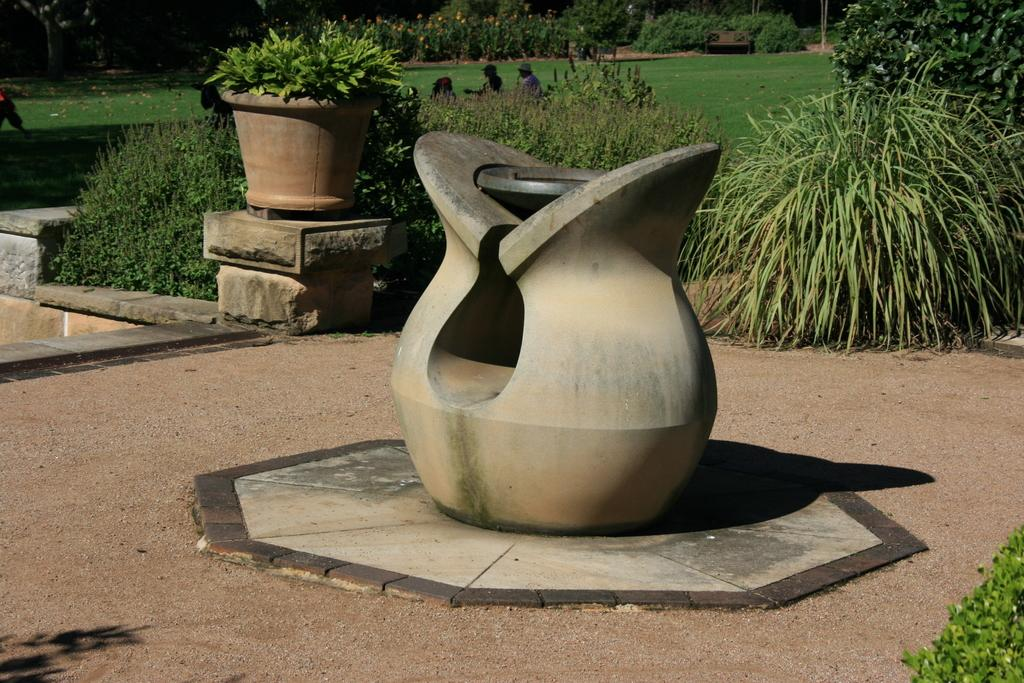What is the main object in the center of the image? There is a pot in the center of the image. What can be seen in the background of the image? There are plants in the background of the image. Are there any people visible in the image? Yes, there are persons in the image. What type of ground is visible in the image? There is grass on the ground in the image. Where is the shop located in the image? There is no shop present in the image. How many pigs can be seen playing on the bridge in the image? There are no pigs or bridge present in the image. 